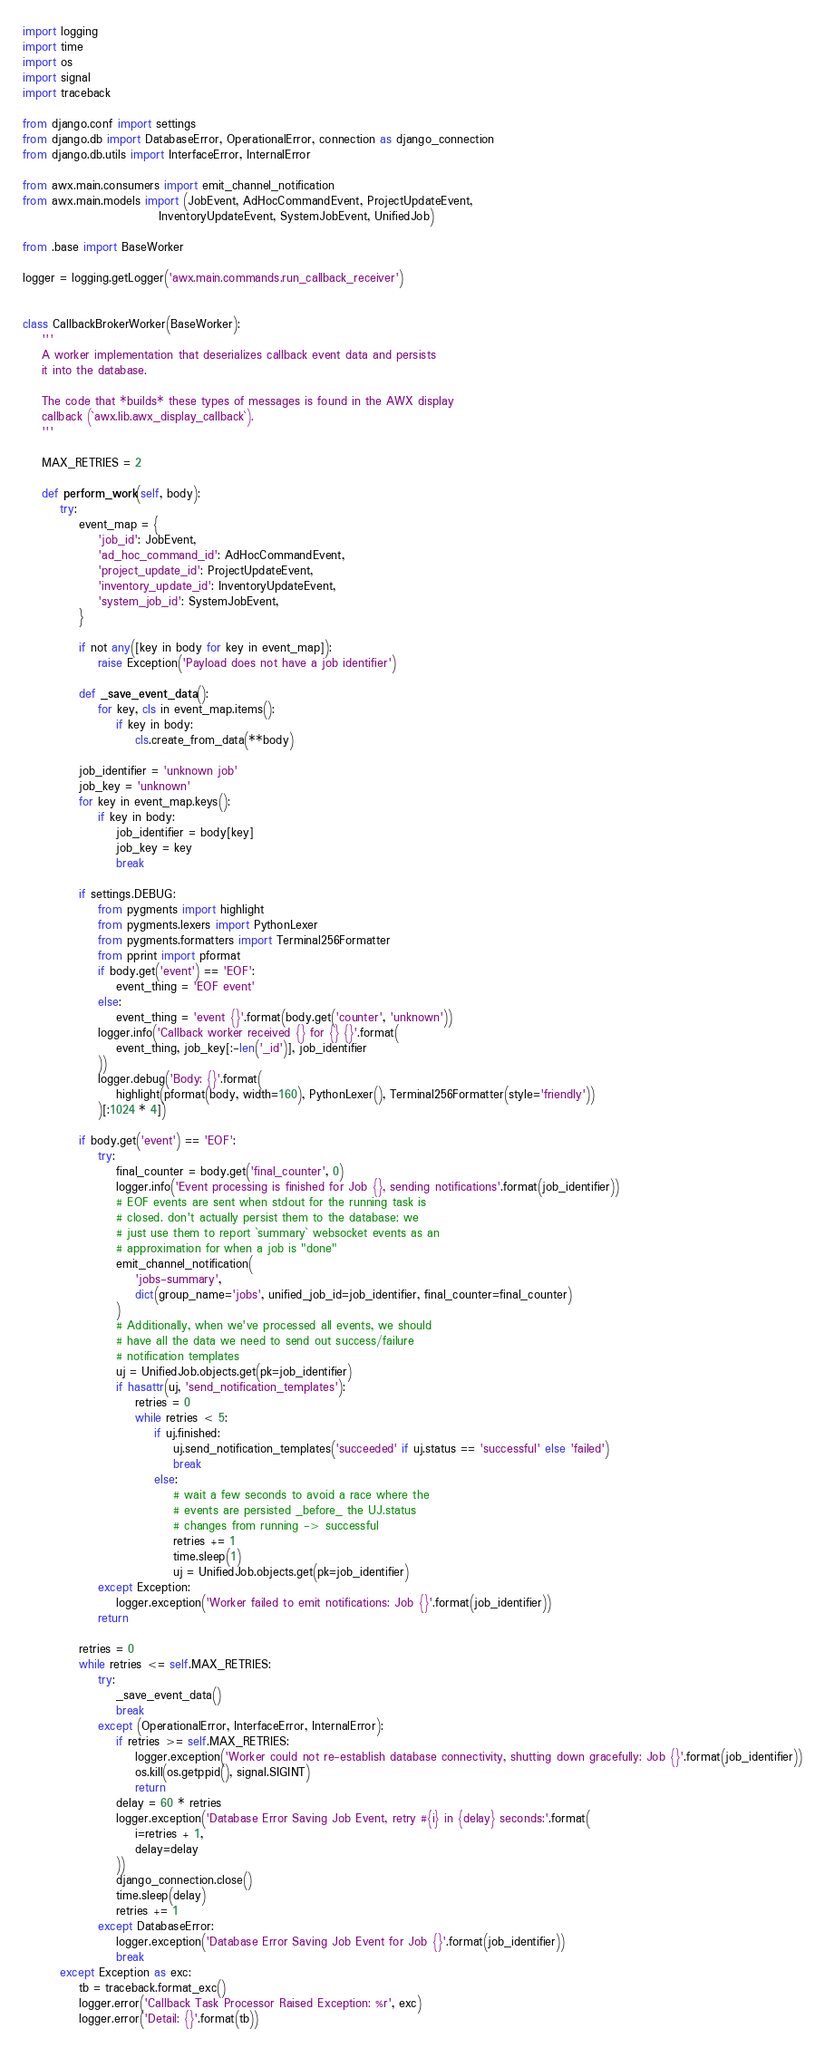Convert code to text. <code><loc_0><loc_0><loc_500><loc_500><_Python_>import logging
import time
import os
import signal
import traceback

from django.conf import settings
from django.db import DatabaseError, OperationalError, connection as django_connection
from django.db.utils import InterfaceError, InternalError

from awx.main.consumers import emit_channel_notification
from awx.main.models import (JobEvent, AdHocCommandEvent, ProjectUpdateEvent,
                             InventoryUpdateEvent, SystemJobEvent, UnifiedJob)

from .base import BaseWorker

logger = logging.getLogger('awx.main.commands.run_callback_receiver')


class CallbackBrokerWorker(BaseWorker):
    '''
    A worker implementation that deserializes callback event data and persists
    it into the database.

    The code that *builds* these types of messages is found in the AWX display
    callback (`awx.lib.awx_display_callback`).
    '''

    MAX_RETRIES = 2

    def perform_work(self, body):
        try:
            event_map = {
                'job_id': JobEvent,
                'ad_hoc_command_id': AdHocCommandEvent,
                'project_update_id': ProjectUpdateEvent,
                'inventory_update_id': InventoryUpdateEvent,
                'system_job_id': SystemJobEvent,
            }

            if not any([key in body for key in event_map]):
                raise Exception('Payload does not have a job identifier')

            def _save_event_data():
                for key, cls in event_map.items():
                    if key in body:
                        cls.create_from_data(**body)

            job_identifier = 'unknown job'
            job_key = 'unknown'
            for key in event_map.keys():
                if key in body:
                    job_identifier = body[key]
                    job_key = key
                    break

            if settings.DEBUG:
                from pygments import highlight
                from pygments.lexers import PythonLexer
                from pygments.formatters import Terminal256Formatter
                from pprint import pformat
                if body.get('event') == 'EOF':
                    event_thing = 'EOF event'
                else:
                    event_thing = 'event {}'.format(body.get('counter', 'unknown'))
                logger.info('Callback worker received {} for {} {}'.format(
                    event_thing, job_key[:-len('_id')], job_identifier
                ))
                logger.debug('Body: {}'.format(
                    highlight(pformat(body, width=160), PythonLexer(), Terminal256Formatter(style='friendly'))
                )[:1024 * 4])

            if body.get('event') == 'EOF':
                try:
                    final_counter = body.get('final_counter', 0)
                    logger.info('Event processing is finished for Job {}, sending notifications'.format(job_identifier))
                    # EOF events are sent when stdout for the running task is
                    # closed. don't actually persist them to the database; we
                    # just use them to report `summary` websocket events as an
                    # approximation for when a job is "done"
                    emit_channel_notification(
                        'jobs-summary',
                        dict(group_name='jobs', unified_job_id=job_identifier, final_counter=final_counter)
                    )
                    # Additionally, when we've processed all events, we should
                    # have all the data we need to send out success/failure
                    # notification templates
                    uj = UnifiedJob.objects.get(pk=job_identifier)
                    if hasattr(uj, 'send_notification_templates'):
                        retries = 0
                        while retries < 5:
                            if uj.finished:
                                uj.send_notification_templates('succeeded' if uj.status == 'successful' else 'failed')
                                break
                            else:
                                # wait a few seconds to avoid a race where the
                                # events are persisted _before_ the UJ.status
                                # changes from running -> successful
                                retries += 1
                                time.sleep(1)
                                uj = UnifiedJob.objects.get(pk=job_identifier)
                except Exception:
                    logger.exception('Worker failed to emit notifications: Job {}'.format(job_identifier))
                return

            retries = 0
            while retries <= self.MAX_RETRIES:
                try:
                    _save_event_data()
                    break
                except (OperationalError, InterfaceError, InternalError):
                    if retries >= self.MAX_RETRIES:
                        logger.exception('Worker could not re-establish database connectivity, shutting down gracefully: Job {}'.format(job_identifier))
                        os.kill(os.getppid(), signal.SIGINT)
                        return
                    delay = 60 * retries
                    logger.exception('Database Error Saving Job Event, retry #{i} in {delay} seconds:'.format(
                        i=retries + 1,
                        delay=delay
                    ))
                    django_connection.close()
                    time.sleep(delay)
                    retries += 1
                except DatabaseError:
                    logger.exception('Database Error Saving Job Event for Job {}'.format(job_identifier))
                    break
        except Exception as exc:
            tb = traceback.format_exc()
            logger.error('Callback Task Processor Raised Exception: %r', exc)
            logger.error('Detail: {}'.format(tb))
</code> 